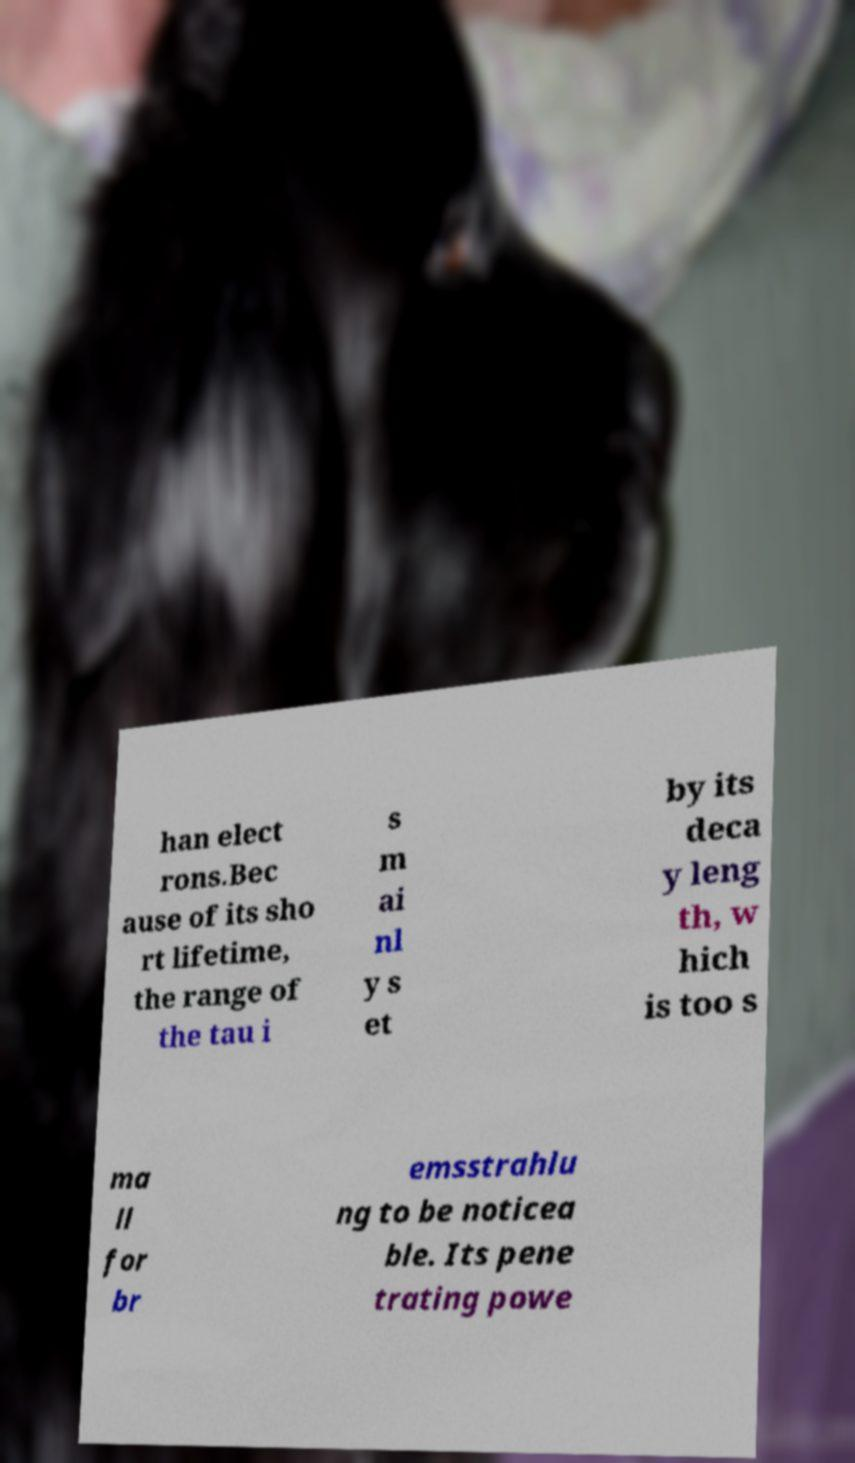Please identify and transcribe the text found in this image. han elect rons.Bec ause of its sho rt lifetime, the range of the tau i s m ai nl y s et by its deca y leng th, w hich is too s ma ll for br emsstrahlu ng to be noticea ble. Its pene trating powe 